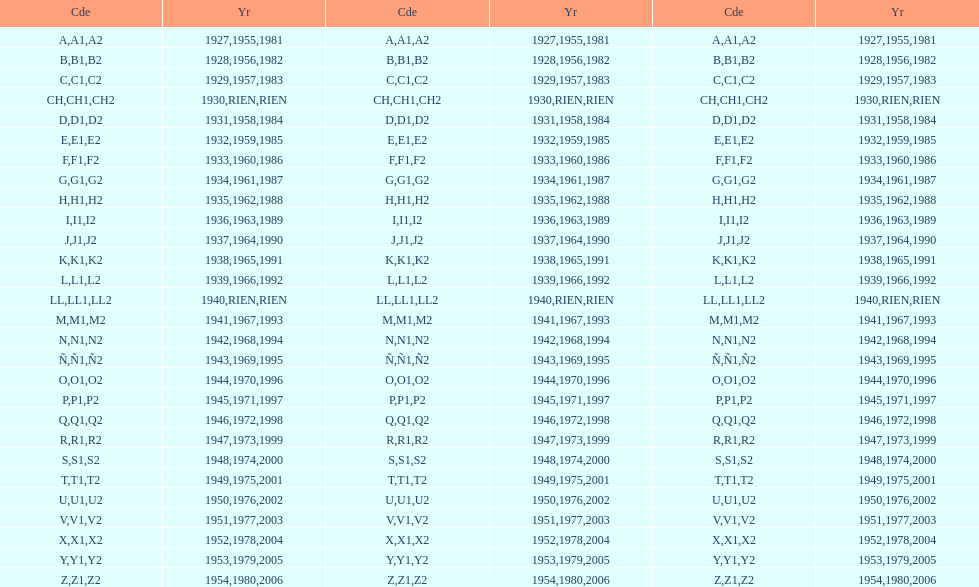Would you mind parsing the complete table? {'header': ['Cde', 'Yr', 'Cde', 'Yr', 'Cde', 'Yr'], 'rows': [['A', '1927', 'A1', '1955', 'A2', '1981'], ['B', '1928', 'B1', '1956', 'B2', '1982'], ['C', '1929', 'C1', '1957', 'C2', '1983'], ['CH', '1930', 'CH1', 'RIEN', 'CH2', 'RIEN'], ['D', '1931', 'D1', '1958', 'D2', '1984'], ['E', '1932', 'E1', '1959', 'E2', '1985'], ['F', '1933', 'F1', '1960', 'F2', '1986'], ['G', '1934', 'G1', '1961', 'G2', '1987'], ['H', '1935', 'H1', '1962', 'H2', '1988'], ['I', '1936', 'I1', '1963', 'I2', '1989'], ['J', '1937', 'J1', '1964', 'J2', '1990'], ['K', '1938', 'K1', '1965', 'K2', '1991'], ['L', '1939', 'L1', '1966', 'L2', '1992'], ['LL', '1940', 'LL1', 'RIEN', 'LL2', 'RIEN'], ['M', '1941', 'M1', '1967', 'M2', '1993'], ['N', '1942', 'N1', '1968', 'N2', '1994'], ['Ñ', '1943', 'Ñ1', '1969', 'Ñ2', '1995'], ['O', '1944', 'O1', '1970', 'O2', '1996'], ['P', '1945', 'P1', '1971', 'P2', '1997'], ['Q', '1946', 'Q1', '1972', 'Q2', '1998'], ['R', '1947', 'R1', '1973', 'R2', '1999'], ['S', '1948', 'S1', '1974', 'S2', '2000'], ['T', '1949', 'T1', '1975', 'T2', '2001'], ['U', '1950', 'U1', '1976', 'U2', '2002'], ['V', '1951', 'V1', '1977', 'V2', '2003'], ['X', '1952', 'X1', '1978', 'X2', '2004'], ['Y', '1953', 'Y1', '1979', 'Y2', '2005'], ['Z', '1954', 'Z1', '1980', 'Z2', '2006']]} What was the lowest year stamped? 1927. 